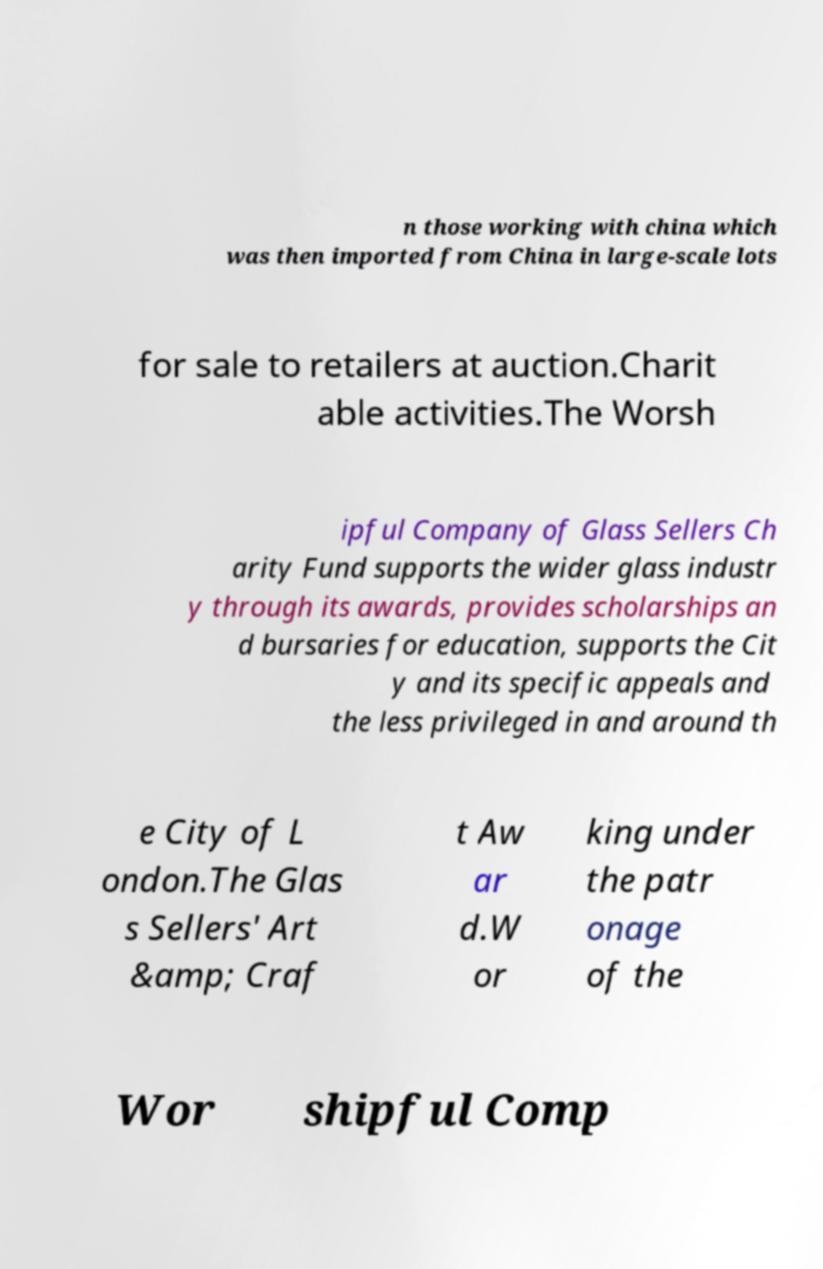Could you assist in decoding the text presented in this image and type it out clearly? n those working with china which was then imported from China in large-scale lots for sale to retailers at auction.Charit able activities.The Worsh ipful Company of Glass Sellers Ch arity Fund supports the wider glass industr y through its awards, provides scholarships an d bursaries for education, supports the Cit y and its specific appeals and the less privileged in and around th e City of L ondon.The Glas s Sellers' Art &amp; Craf t Aw ar d.W or king under the patr onage of the Wor shipful Comp 